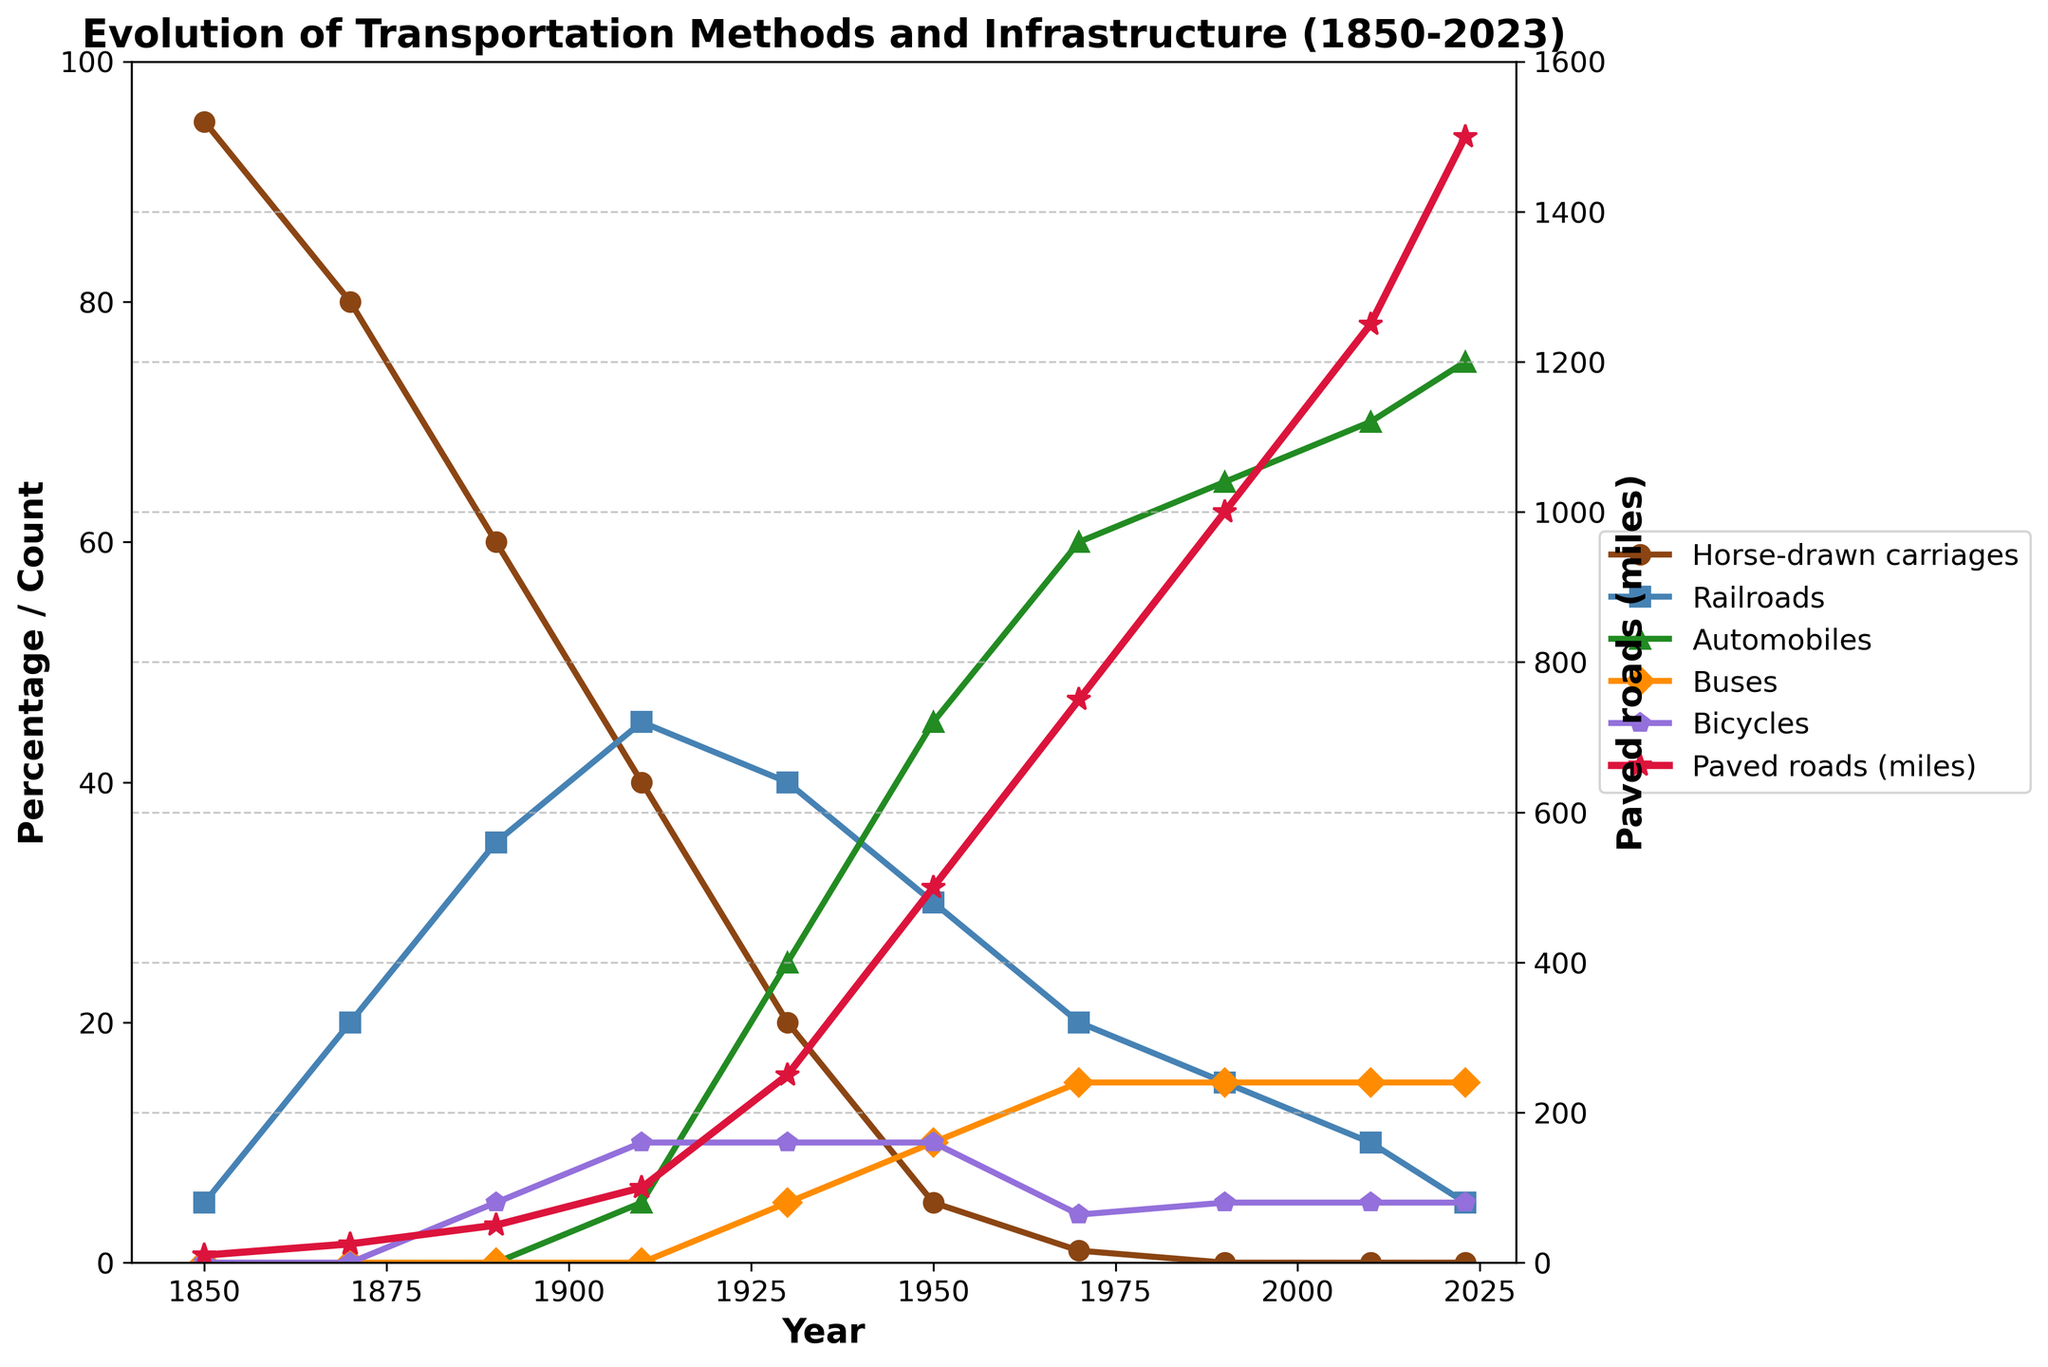When do automobiles surpass railroads in usage? Automobiles surpass railroads around 1930, as seen where the blue line (railroads) drops below the green line (automobiles) in the plot.
Answer: 1930 What is the total number of bicycles and buses in 1950? In 1950, there are 10 buses and 10 bicycles. Summing them up: 10 + 10 = 20.
Answer: 20 Which transportation method had the most significant decrease from 1850 to 2023? Horse-drawn carriages decrease from 95 to 0 from 1850 to 2023, which is the most significant decline among all methods shown in the plot.
Answer: Horse-drawn carriages Between 1910 and 1930, what was the increase in paved road miles? In 1910, there were 100 miles of paved roads, and in 1930, there were 250 miles. The increase can be calculated as 250 - 100 = 150 miles.
Answer: 150 miles Which transportation method had the highest value in 2023? In 2023, automobiles had the highest value among all the transportation methods shown in the plot.
Answer: Automobiles How many more automobiles than railroads were there in 2023? In 2023, there are 75 automobiles and 5 railroads. The difference can be calculated as 75 - 5 = 70.
Answer: 70 By how many miles did paved roads increase between 1990 and 2023? Paved roads increased from 1000 miles in 1990 to 1500 miles in 2023. The increase can be calculated as 1500 - 1000 = 500 miles.
Answer: 500 miles Which two transportation methods had the same number of units in 2010? In 2010, both buses and bicycles had the same value of 15 units as depicted in the plot.
Answer: Buses and bicycles In what year do buses appear in the figure for the first time? Buses appear for the first time in the figure in 1930.
Answer: 1930 What is the average number of horse-drawn carriages from 1850 to 1930? From 1850 to 1930, the number of horse-drawn carriages is 95, 80, 60, 40, and 20. The average can be calculated as (95 + 80 + 60 + 40 + 20) / 5 = 59.
Answer: 59 